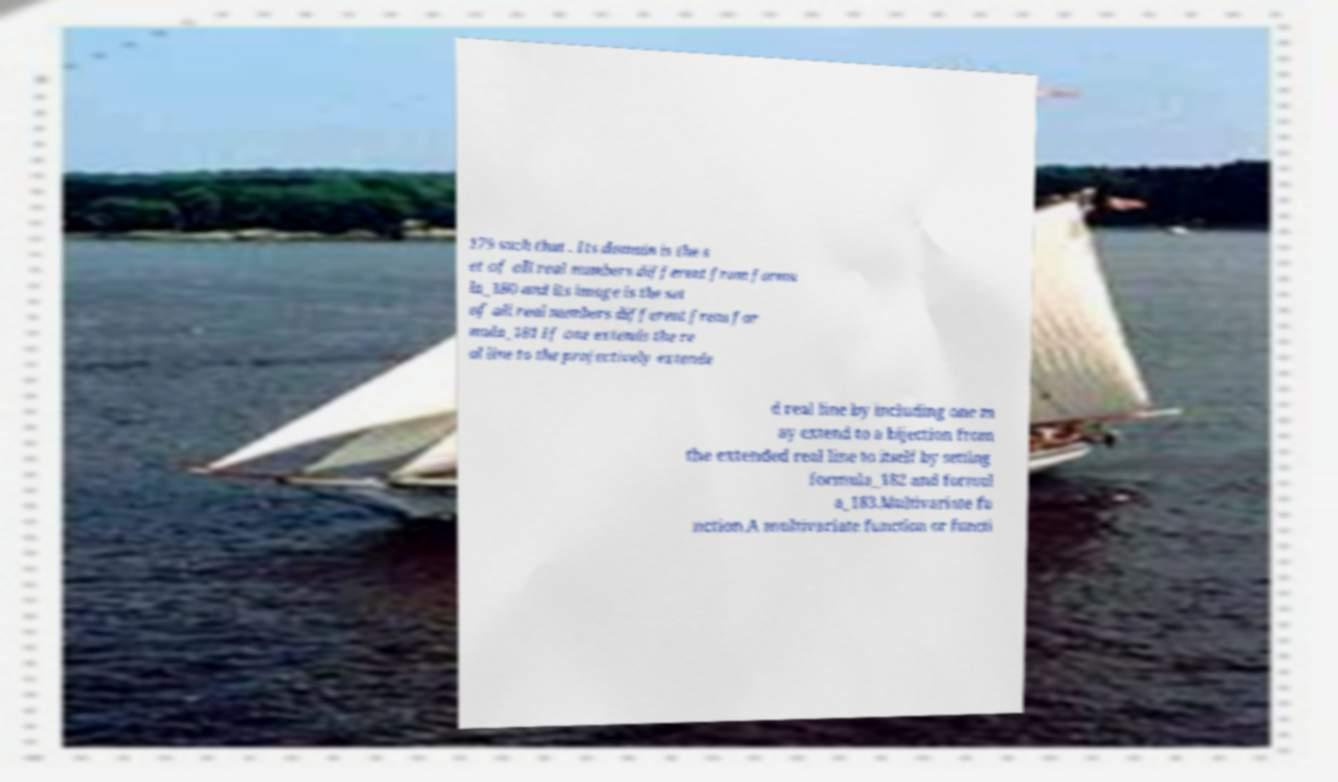Could you assist in decoding the text presented in this image and type it out clearly? 179 such that . Its domain is the s et of all real numbers different from formu la_180 and its image is the set of all real numbers different from for mula_181 If one extends the re al line to the projectively extende d real line by including one m ay extend to a bijection from the extended real line to itself by setting formula_182 and formul a_183.Multivariate fu nction.A multivariate function or functi 